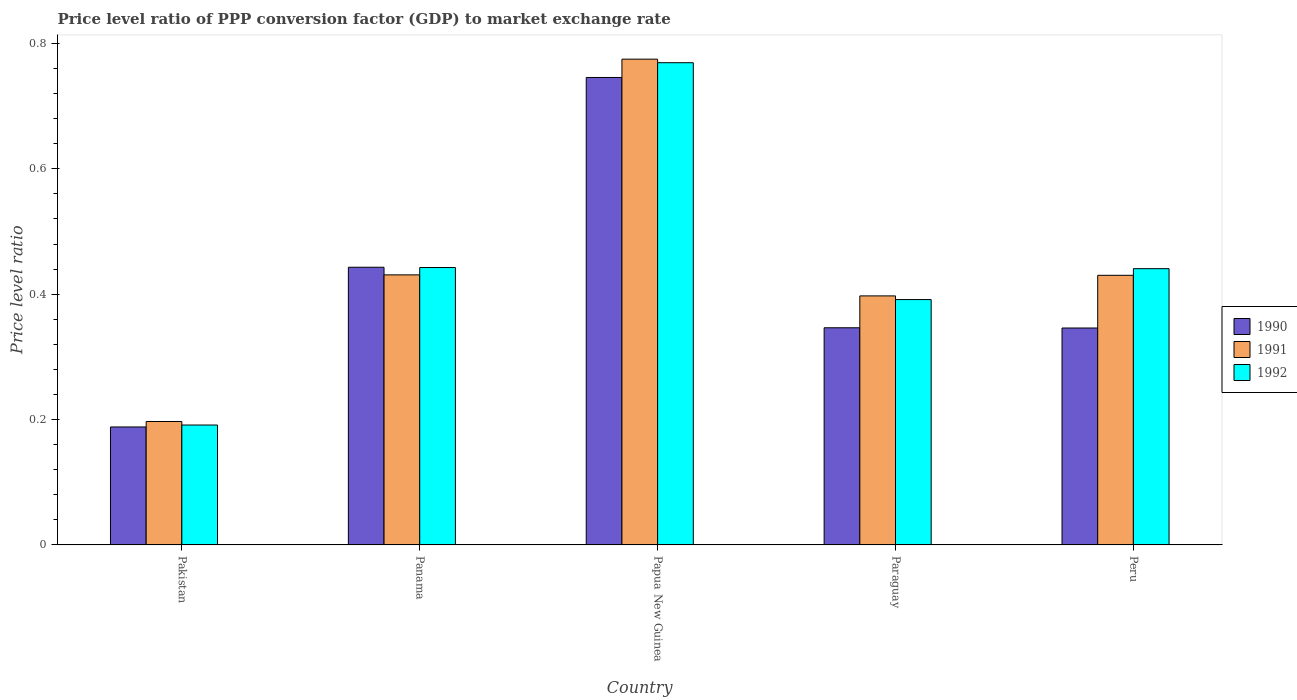How many groups of bars are there?
Your answer should be very brief. 5. Are the number of bars per tick equal to the number of legend labels?
Provide a short and direct response. Yes. How many bars are there on the 2nd tick from the left?
Provide a short and direct response. 3. What is the label of the 3rd group of bars from the left?
Offer a very short reply. Papua New Guinea. In how many cases, is the number of bars for a given country not equal to the number of legend labels?
Your answer should be compact. 0. What is the price level ratio in 1990 in Papua New Guinea?
Give a very brief answer. 0.75. Across all countries, what is the maximum price level ratio in 1992?
Your response must be concise. 0.77. Across all countries, what is the minimum price level ratio in 1991?
Provide a short and direct response. 0.2. In which country was the price level ratio in 1991 maximum?
Provide a short and direct response. Papua New Guinea. What is the total price level ratio in 1991 in the graph?
Make the answer very short. 2.23. What is the difference between the price level ratio in 1991 in Papua New Guinea and that in Peru?
Ensure brevity in your answer.  0.34. What is the difference between the price level ratio in 1991 in Peru and the price level ratio in 1992 in Paraguay?
Offer a very short reply. 0.04. What is the average price level ratio in 1991 per country?
Provide a succinct answer. 0.45. What is the difference between the price level ratio of/in 1992 and price level ratio of/in 1990 in Paraguay?
Provide a succinct answer. 0.04. In how many countries, is the price level ratio in 1992 greater than 0.12?
Keep it short and to the point. 5. What is the ratio of the price level ratio in 1992 in Papua New Guinea to that in Peru?
Your answer should be compact. 1.75. Is the difference between the price level ratio in 1992 in Pakistan and Peru greater than the difference between the price level ratio in 1990 in Pakistan and Peru?
Your answer should be very brief. No. What is the difference between the highest and the second highest price level ratio in 1990?
Give a very brief answer. 0.3. What is the difference between the highest and the lowest price level ratio in 1991?
Provide a short and direct response. 0.58. What does the 1st bar from the left in Papua New Guinea represents?
Provide a short and direct response. 1990. How many bars are there?
Your answer should be very brief. 15. Are all the bars in the graph horizontal?
Offer a very short reply. No. How many countries are there in the graph?
Provide a short and direct response. 5. Are the values on the major ticks of Y-axis written in scientific E-notation?
Offer a very short reply. No. Does the graph contain any zero values?
Your answer should be very brief. No. Does the graph contain grids?
Provide a succinct answer. No. How many legend labels are there?
Your response must be concise. 3. How are the legend labels stacked?
Offer a terse response. Vertical. What is the title of the graph?
Provide a succinct answer. Price level ratio of PPP conversion factor (GDP) to market exchange rate. What is the label or title of the Y-axis?
Keep it short and to the point. Price level ratio. What is the Price level ratio in 1990 in Pakistan?
Provide a short and direct response. 0.19. What is the Price level ratio of 1991 in Pakistan?
Offer a terse response. 0.2. What is the Price level ratio of 1992 in Pakistan?
Offer a very short reply. 0.19. What is the Price level ratio of 1990 in Panama?
Give a very brief answer. 0.44. What is the Price level ratio in 1991 in Panama?
Give a very brief answer. 0.43. What is the Price level ratio in 1992 in Panama?
Ensure brevity in your answer.  0.44. What is the Price level ratio in 1990 in Papua New Guinea?
Provide a succinct answer. 0.75. What is the Price level ratio of 1991 in Papua New Guinea?
Your answer should be very brief. 0.77. What is the Price level ratio in 1992 in Papua New Guinea?
Give a very brief answer. 0.77. What is the Price level ratio in 1990 in Paraguay?
Offer a very short reply. 0.35. What is the Price level ratio of 1991 in Paraguay?
Make the answer very short. 0.4. What is the Price level ratio of 1992 in Paraguay?
Make the answer very short. 0.39. What is the Price level ratio of 1990 in Peru?
Ensure brevity in your answer.  0.35. What is the Price level ratio in 1991 in Peru?
Make the answer very short. 0.43. What is the Price level ratio of 1992 in Peru?
Ensure brevity in your answer.  0.44. Across all countries, what is the maximum Price level ratio of 1990?
Your answer should be compact. 0.75. Across all countries, what is the maximum Price level ratio of 1991?
Your answer should be compact. 0.77. Across all countries, what is the maximum Price level ratio in 1992?
Your answer should be compact. 0.77. Across all countries, what is the minimum Price level ratio of 1990?
Make the answer very short. 0.19. Across all countries, what is the minimum Price level ratio of 1991?
Your answer should be compact. 0.2. Across all countries, what is the minimum Price level ratio of 1992?
Your answer should be very brief. 0.19. What is the total Price level ratio of 1990 in the graph?
Ensure brevity in your answer.  2.07. What is the total Price level ratio in 1991 in the graph?
Your answer should be compact. 2.23. What is the total Price level ratio of 1992 in the graph?
Keep it short and to the point. 2.24. What is the difference between the Price level ratio of 1990 in Pakistan and that in Panama?
Offer a very short reply. -0.25. What is the difference between the Price level ratio of 1991 in Pakistan and that in Panama?
Offer a terse response. -0.23. What is the difference between the Price level ratio in 1992 in Pakistan and that in Panama?
Provide a short and direct response. -0.25. What is the difference between the Price level ratio in 1990 in Pakistan and that in Papua New Guinea?
Give a very brief answer. -0.56. What is the difference between the Price level ratio of 1991 in Pakistan and that in Papua New Guinea?
Keep it short and to the point. -0.58. What is the difference between the Price level ratio in 1992 in Pakistan and that in Papua New Guinea?
Your answer should be compact. -0.58. What is the difference between the Price level ratio in 1990 in Pakistan and that in Paraguay?
Offer a terse response. -0.16. What is the difference between the Price level ratio of 1991 in Pakistan and that in Paraguay?
Your response must be concise. -0.2. What is the difference between the Price level ratio of 1992 in Pakistan and that in Paraguay?
Keep it short and to the point. -0.2. What is the difference between the Price level ratio in 1990 in Pakistan and that in Peru?
Provide a short and direct response. -0.16. What is the difference between the Price level ratio of 1991 in Pakistan and that in Peru?
Provide a short and direct response. -0.23. What is the difference between the Price level ratio of 1992 in Pakistan and that in Peru?
Provide a succinct answer. -0.25. What is the difference between the Price level ratio in 1990 in Panama and that in Papua New Guinea?
Your answer should be very brief. -0.3. What is the difference between the Price level ratio of 1991 in Panama and that in Papua New Guinea?
Make the answer very short. -0.34. What is the difference between the Price level ratio in 1992 in Panama and that in Papua New Guinea?
Give a very brief answer. -0.33. What is the difference between the Price level ratio in 1990 in Panama and that in Paraguay?
Your answer should be compact. 0.1. What is the difference between the Price level ratio of 1991 in Panama and that in Paraguay?
Offer a terse response. 0.03. What is the difference between the Price level ratio of 1992 in Panama and that in Paraguay?
Your answer should be compact. 0.05. What is the difference between the Price level ratio of 1990 in Panama and that in Peru?
Keep it short and to the point. 0.1. What is the difference between the Price level ratio in 1991 in Panama and that in Peru?
Give a very brief answer. 0. What is the difference between the Price level ratio in 1992 in Panama and that in Peru?
Provide a succinct answer. 0. What is the difference between the Price level ratio of 1990 in Papua New Guinea and that in Paraguay?
Give a very brief answer. 0.4. What is the difference between the Price level ratio of 1991 in Papua New Guinea and that in Paraguay?
Provide a succinct answer. 0.38. What is the difference between the Price level ratio of 1992 in Papua New Guinea and that in Paraguay?
Your answer should be very brief. 0.38. What is the difference between the Price level ratio in 1990 in Papua New Guinea and that in Peru?
Your answer should be compact. 0.4. What is the difference between the Price level ratio of 1991 in Papua New Guinea and that in Peru?
Provide a succinct answer. 0.34. What is the difference between the Price level ratio of 1992 in Papua New Guinea and that in Peru?
Offer a terse response. 0.33. What is the difference between the Price level ratio of 1990 in Paraguay and that in Peru?
Give a very brief answer. 0. What is the difference between the Price level ratio in 1991 in Paraguay and that in Peru?
Provide a short and direct response. -0.03. What is the difference between the Price level ratio of 1992 in Paraguay and that in Peru?
Offer a terse response. -0.05. What is the difference between the Price level ratio of 1990 in Pakistan and the Price level ratio of 1991 in Panama?
Provide a succinct answer. -0.24. What is the difference between the Price level ratio of 1990 in Pakistan and the Price level ratio of 1992 in Panama?
Give a very brief answer. -0.25. What is the difference between the Price level ratio of 1991 in Pakistan and the Price level ratio of 1992 in Panama?
Your answer should be compact. -0.25. What is the difference between the Price level ratio in 1990 in Pakistan and the Price level ratio in 1991 in Papua New Guinea?
Ensure brevity in your answer.  -0.59. What is the difference between the Price level ratio of 1990 in Pakistan and the Price level ratio of 1992 in Papua New Guinea?
Offer a very short reply. -0.58. What is the difference between the Price level ratio in 1991 in Pakistan and the Price level ratio in 1992 in Papua New Guinea?
Offer a terse response. -0.57. What is the difference between the Price level ratio in 1990 in Pakistan and the Price level ratio in 1991 in Paraguay?
Provide a succinct answer. -0.21. What is the difference between the Price level ratio of 1990 in Pakistan and the Price level ratio of 1992 in Paraguay?
Your answer should be compact. -0.2. What is the difference between the Price level ratio of 1991 in Pakistan and the Price level ratio of 1992 in Paraguay?
Make the answer very short. -0.19. What is the difference between the Price level ratio in 1990 in Pakistan and the Price level ratio in 1991 in Peru?
Your response must be concise. -0.24. What is the difference between the Price level ratio in 1990 in Pakistan and the Price level ratio in 1992 in Peru?
Make the answer very short. -0.25. What is the difference between the Price level ratio of 1991 in Pakistan and the Price level ratio of 1992 in Peru?
Give a very brief answer. -0.24. What is the difference between the Price level ratio in 1990 in Panama and the Price level ratio in 1991 in Papua New Guinea?
Offer a terse response. -0.33. What is the difference between the Price level ratio in 1990 in Panama and the Price level ratio in 1992 in Papua New Guinea?
Offer a very short reply. -0.33. What is the difference between the Price level ratio in 1991 in Panama and the Price level ratio in 1992 in Papua New Guinea?
Give a very brief answer. -0.34. What is the difference between the Price level ratio of 1990 in Panama and the Price level ratio of 1991 in Paraguay?
Provide a succinct answer. 0.05. What is the difference between the Price level ratio in 1990 in Panama and the Price level ratio in 1992 in Paraguay?
Your answer should be compact. 0.05. What is the difference between the Price level ratio of 1991 in Panama and the Price level ratio of 1992 in Paraguay?
Offer a very short reply. 0.04. What is the difference between the Price level ratio of 1990 in Panama and the Price level ratio of 1991 in Peru?
Provide a short and direct response. 0.01. What is the difference between the Price level ratio in 1990 in Panama and the Price level ratio in 1992 in Peru?
Your answer should be very brief. 0. What is the difference between the Price level ratio of 1991 in Panama and the Price level ratio of 1992 in Peru?
Give a very brief answer. -0.01. What is the difference between the Price level ratio of 1990 in Papua New Guinea and the Price level ratio of 1991 in Paraguay?
Your response must be concise. 0.35. What is the difference between the Price level ratio of 1990 in Papua New Guinea and the Price level ratio of 1992 in Paraguay?
Your response must be concise. 0.35. What is the difference between the Price level ratio of 1991 in Papua New Guinea and the Price level ratio of 1992 in Paraguay?
Your response must be concise. 0.38. What is the difference between the Price level ratio of 1990 in Papua New Guinea and the Price level ratio of 1991 in Peru?
Your answer should be compact. 0.32. What is the difference between the Price level ratio of 1990 in Papua New Guinea and the Price level ratio of 1992 in Peru?
Provide a succinct answer. 0.3. What is the difference between the Price level ratio in 1991 in Papua New Guinea and the Price level ratio in 1992 in Peru?
Your answer should be compact. 0.33. What is the difference between the Price level ratio in 1990 in Paraguay and the Price level ratio in 1991 in Peru?
Give a very brief answer. -0.08. What is the difference between the Price level ratio of 1990 in Paraguay and the Price level ratio of 1992 in Peru?
Your answer should be very brief. -0.09. What is the difference between the Price level ratio of 1991 in Paraguay and the Price level ratio of 1992 in Peru?
Ensure brevity in your answer.  -0.04. What is the average Price level ratio in 1990 per country?
Your response must be concise. 0.41. What is the average Price level ratio in 1991 per country?
Your answer should be very brief. 0.45. What is the average Price level ratio of 1992 per country?
Your answer should be very brief. 0.45. What is the difference between the Price level ratio of 1990 and Price level ratio of 1991 in Pakistan?
Provide a succinct answer. -0.01. What is the difference between the Price level ratio in 1990 and Price level ratio in 1992 in Pakistan?
Keep it short and to the point. -0. What is the difference between the Price level ratio in 1991 and Price level ratio in 1992 in Pakistan?
Provide a short and direct response. 0.01. What is the difference between the Price level ratio of 1990 and Price level ratio of 1991 in Panama?
Provide a short and direct response. 0.01. What is the difference between the Price level ratio of 1990 and Price level ratio of 1992 in Panama?
Provide a succinct answer. 0. What is the difference between the Price level ratio in 1991 and Price level ratio in 1992 in Panama?
Ensure brevity in your answer.  -0.01. What is the difference between the Price level ratio in 1990 and Price level ratio in 1991 in Papua New Guinea?
Your answer should be compact. -0.03. What is the difference between the Price level ratio in 1990 and Price level ratio in 1992 in Papua New Guinea?
Give a very brief answer. -0.02. What is the difference between the Price level ratio in 1991 and Price level ratio in 1992 in Papua New Guinea?
Make the answer very short. 0.01. What is the difference between the Price level ratio in 1990 and Price level ratio in 1991 in Paraguay?
Your answer should be very brief. -0.05. What is the difference between the Price level ratio of 1990 and Price level ratio of 1992 in Paraguay?
Your answer should be compact. -0.04. What is the difference between the Price level ratio of 1991 and Price level ratio of 1992 in Paraguay?
Offer a terse response. 0.01. What is the difference between the Price level ratio of 1990 and Price level ratio of 1991 in Peru?
Your answer should be compact. -0.08. What is the difference between the Price level ratio of 1990 and Price level ratio of 1992 in Peru?
Offer a very short reply. -0.09. What is the difference between the Price level ratio in 1991 and Price level ratio in 1992 in Peru?
Your response must be concise. -0.01. What is the ratio of the Price level ratio of 1990 in Pakistan to that in Panama?
Your answer should be very brief. 0.42. What is the ratio of the Price level ratio in 1991 in Pakistan to that in Panama?
Provide a short and direct response. 0.46. What is the ratio of the Price level ratio of 1992 in Pakistan to that in Panama?
Offer a very short reply. 0.43. What is the ratio of the Price level ratio of 1990 in Pakistan to that in Papua New Guinea?
Provide a short and direct response. 0.25. What is the ratio of the Price level ratio in 1991 in Pakistan to that in Papua New Guinea?
Make the answer very short. 0.25. What is the ratio of the Price level ratio of 1992 in Pakistan to that in Papua New Guinea?
Provide a succinct answer. 0.25. What is the ratio of the Price level ratio of 1990 in Pakistan to that in Paraguay?
Provide a succinct answer. 0.54. What is the ratio of the Price level ratio of 1991 in Pakistan to that in Paraguay?
Your response must be concise. 0.5. What is the ratio of the Price level ratio in 1992 in Pakistan to that in Paraguay?
Provide a succinct answer. 0.49. What is the ratio of the Price level ratio in 1990 in Pakistan to that in Peru?
Your response must be concise. 0.54. What is the ratio of the Price level ratio of 1991 in Pakistan to that in Peru?
Your answer should be very brief. 0.46. What is the ratio of the Price level ratio of 1992 in Pakistan to that in Peru?
Provide a succinct answer. 0.43. What is the ratio of the Price level ratio of 1990 in Panama to that in Papua New Guinea?
Ensure brevity in your answer.  0.59. What is the ratio of the Price level ratio in 1991 in Panama to that in Papua New Guinea?
Your response must be concise. 0.56. What is the ratio of the Price level ratio in 1992 in Panama to that in Papua New Guinea?
Your answer should be compact. 0.58. What is the ratio of the Price level ratio of 1990 in Panama to that in Paraguay?
Your answer should be compact. 1.28. What is the ratio of the Price level ratio of 1991 in Panama to that in Paraguay?
Ensure brevity in your answer.  1.08. What is the ratio of the Price level ratio in 1992 in Panama to that in Paraguay?
Provide a short and direct response. 1.13. What is the ratio of the Price level ratio of 1990 in Panama to that in Peru?
Ensure brevity in your answer.  1.28. What is the ratio of the Price level ratio of 1991 in Panama to that in Peru?
Your response must be concise. 1. What is the ratio of the Price level ratio in 1992 in Panama to that in Peru?
Give a very brief answer. 1. What is the ratio of the Price level ratio of 1990 in Papua New Guinea to that in Paraguay?
Provide a short and direct response. 2.15. What is the ratio of the Price level ratio in 1991 in Papua New Guinea to that in Paraguay?
Your response must be concise. 1.95. What is the ratio of the Price level ratio of 1992 in Papua New Guinea to that in Paraguay?
Provide a succinct answer. 1.97. What is the ratio of the Price level ratio in 1990 in Papua New Guinea to that in Peru?
Your answer should be very brief. 2.15. What is the ratio of the Price level ratio in 1991 in Papua New Guinea to that in Peru?
Provide a short and direct response. 1.8. What is the ratio of the Price level ratio in 1992 in Papua New Guinea to that in Peru?
Your answer should be very brief. 1.75. What is the ratio of the Price level ratio of 1990 in Paraguay to that in Peru?
Offer a very short reply. 1. What is the ratio of the Price level ratio in 1991 in Paraguay to that in Peru?
Give a very brief answer. 0.92. What is the ratio of the Price level ratio in 1992 in Paraguay to that in Peru?
Provide a succinct answer. 0.89. What is the difference between the highest and the second highest Price level ratio of 1990?
Ensure brevity in your answer.  0.3. What is the difference between the highest and the second highest Price level ratio in 1991?
Ensure brevity in your answer.  0.34. What is the difference between the highest and the second highest Price level ratio of 1992?
Your answer should be compact. 0.33. What is the difference between the highest and the lowest Price level ratio in 1990?
Offer a very short reply. 0.56. What is the difference between the highest and the lowest Price level ratio in 1991?
Provide a succinct answer. 0.58. What is the difference between the highest and the lowest Price level ratio in 1992?
Offer a terse response. 0.58. 